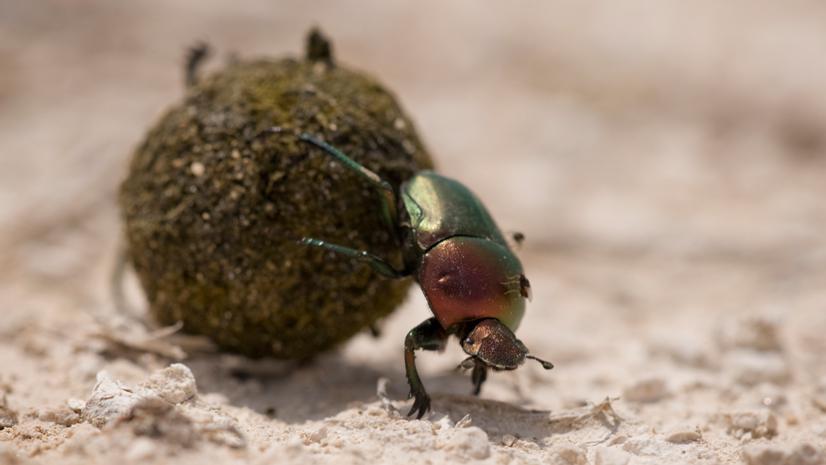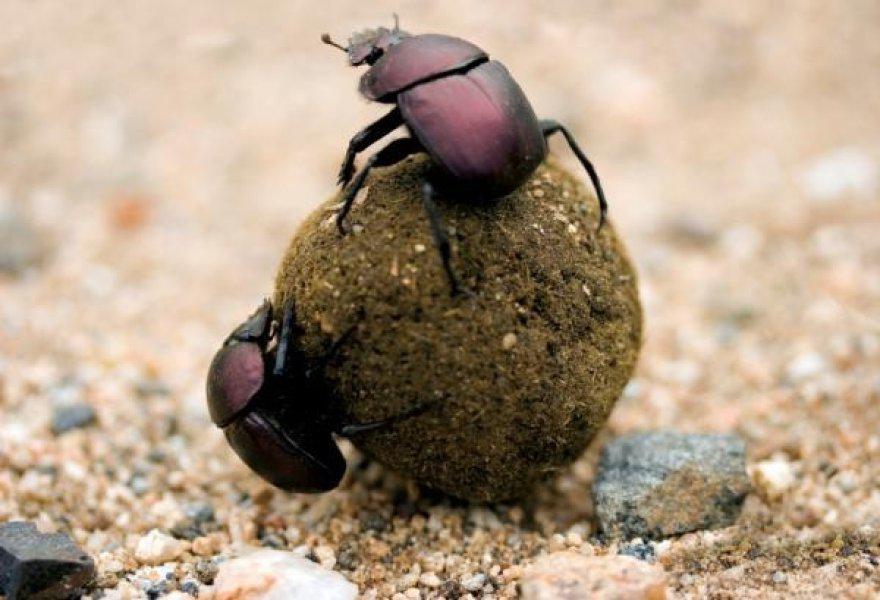The first image is the image on the left, the second image is the image on the right. Analyze the images presented: Is the assertion "Every image has a single beetle and a single dungball." valid? Answer yes or no. No. The first image is the image on the left, the second image is the image on the right. Evaluate the accuracy of this statement regarding the images: "One image contains two beetles and a single brown ball.". Is it true? Answer yes or no. Yes. 